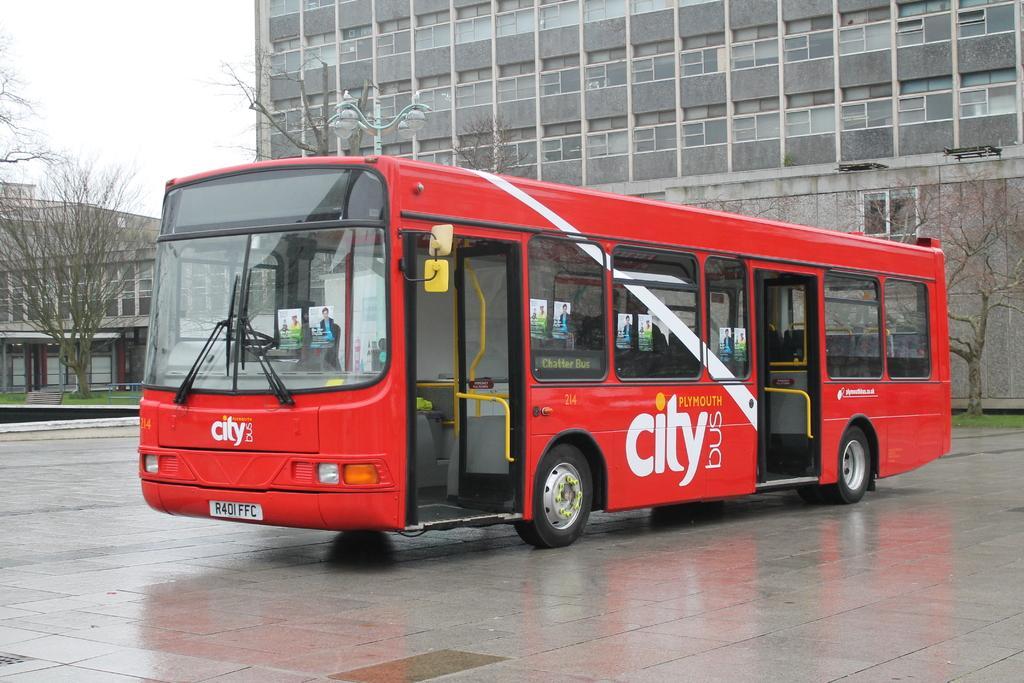In one or two sentences, can you explain what this image depicts? In the middle of this image, there is a red color bus on the road. In the background, there are lights attached to the pole, there are trees, buildings and grass on the ground and there are clouds in the sky. 